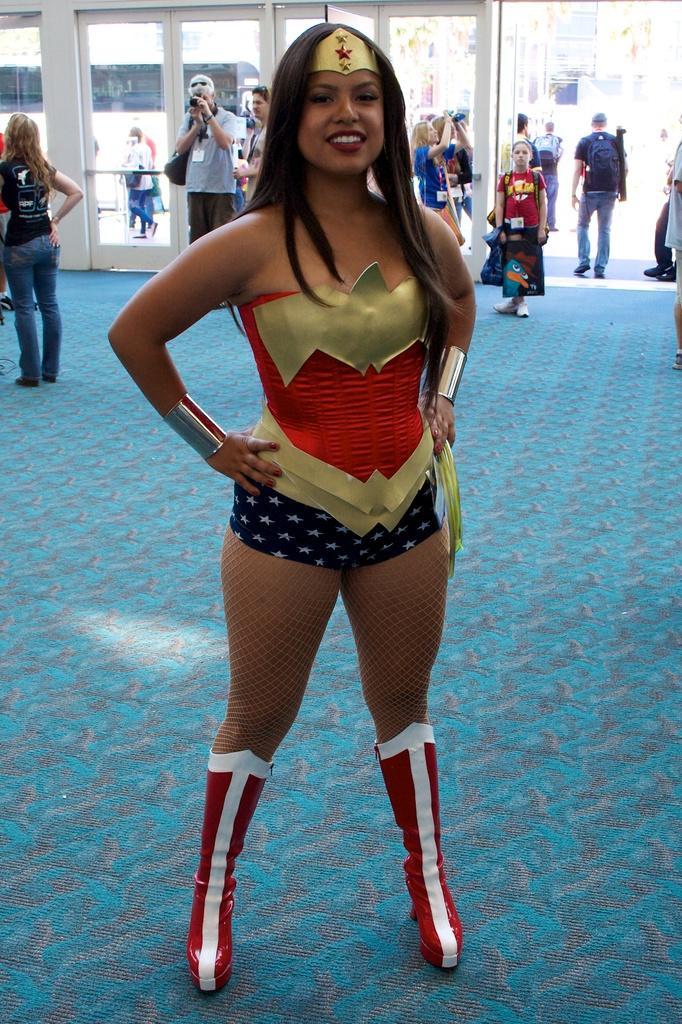Describe this image in one or two sentences. In this image I can see a woman is standing, at the back side there are few people. 